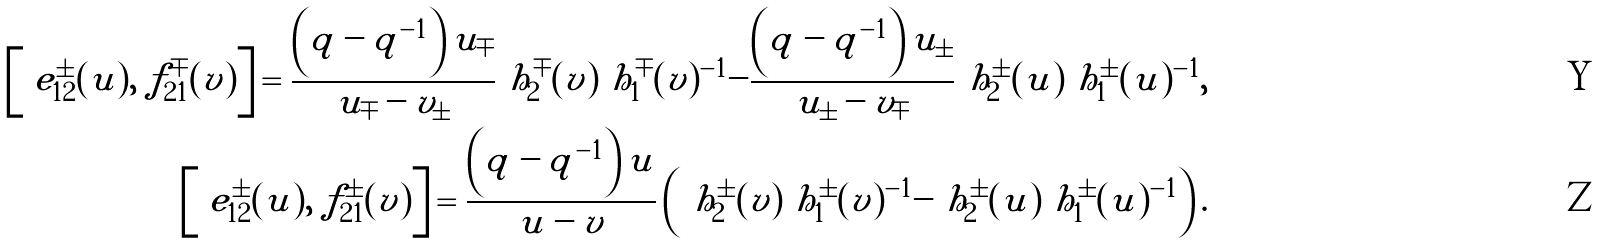<formula> <loc_0><loc_0><loc_500><loc_500>\left [ \ e _ { 1 2 } ^ { \pm } ( u ) , \ f _ { 2 1 } ^ { \mp } ( v ) \right ] = \frac { \left ( q - q ^ { - 1 } \right ) u _ { \mp } } { u _ { \mp } - v _ { \pm } } \ h _ { 2 } ^ { \mp } ( v ) \ h _ { 1 } ^ { \mp } ( v ) ^ { - 1 } - \frac { \left ( q - q ^ { - 1 } \right ) u _ { \pm } } { u _ { \pm } - v _ { \mp } } \ h _ { 2 } ^ { \pm } ( u ) \ h _ { 1 } ^ { \pm } ( u ) ^ { - 1 } , \\ \left [ \ e _ { 1 2 } ^ { \pm } ( u ) , \ f _ { 2 1 } ^ { \pm } ( v ) \right ] = \frac { \left ( q - q ^ { - 1 } \right ) u } { u - v } \left ( \ h _ { 2 } ^ { \pm } ( v ) \ h _ { 1 } ^ { \pm } ( v ) ^ { - 1 } - \ h _ { 2 } ^ { \pm } ( u ) \ h _ { 1 } ^ { \pm } ( u ) ^ { - 1 } \right ) .</formula> 